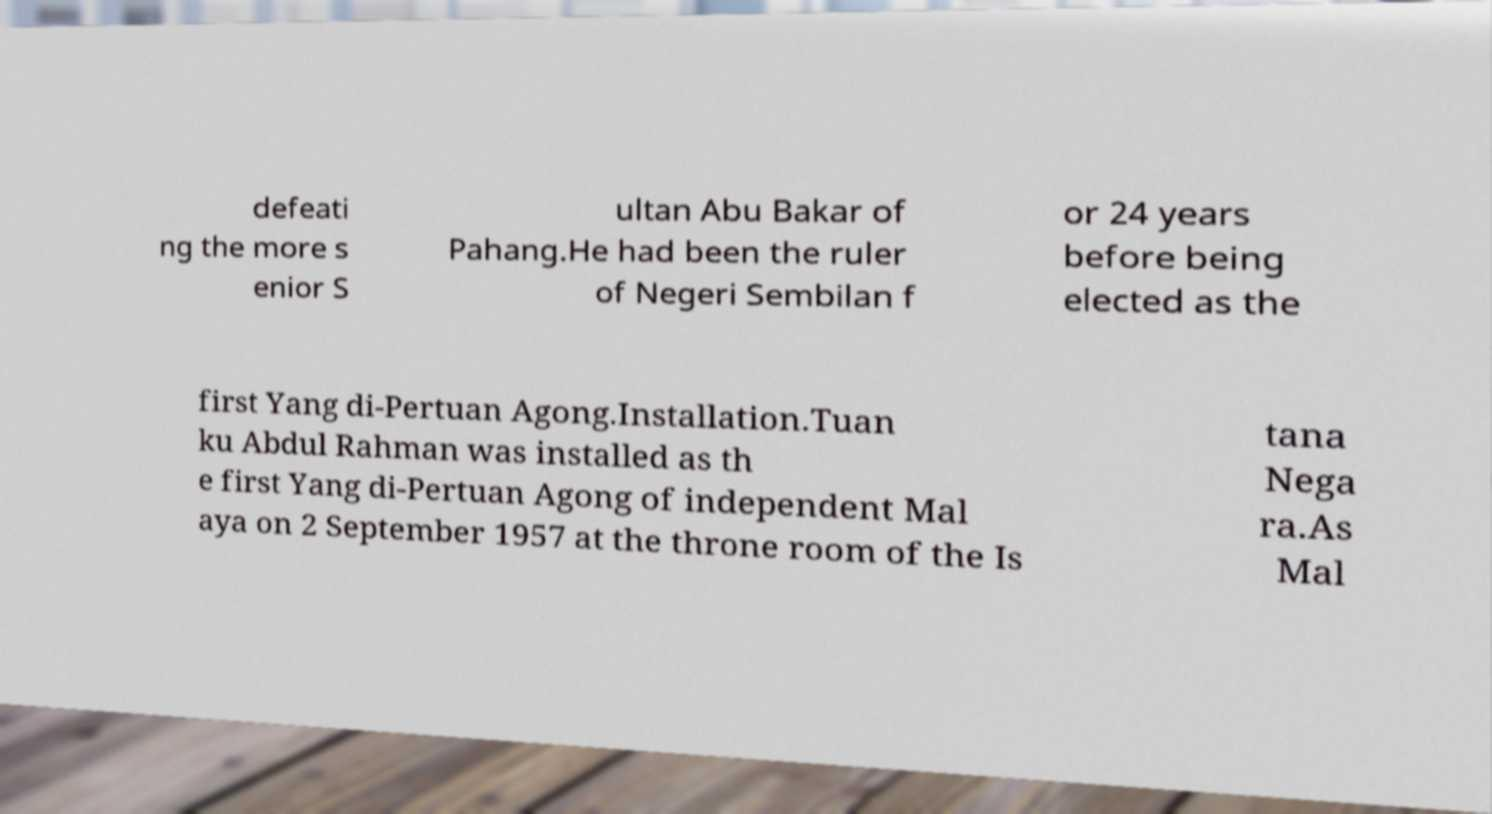Could you assist in decoding the text presented in this image and type it out clearly? defeati ng the more s enior S ultan Abu Bakar of Pahang.He had been the ruler of Negeri Sembilan f or 24 years before being elected as the first Yang di-Pertuan Agong.Installation.Tuan ku Abdul Rahman was installed as th e first Yang di-Pertuan Agong of independent Mal aya on 2 September 1957 at the throne room of the Is tana Nega ra.As Mal 